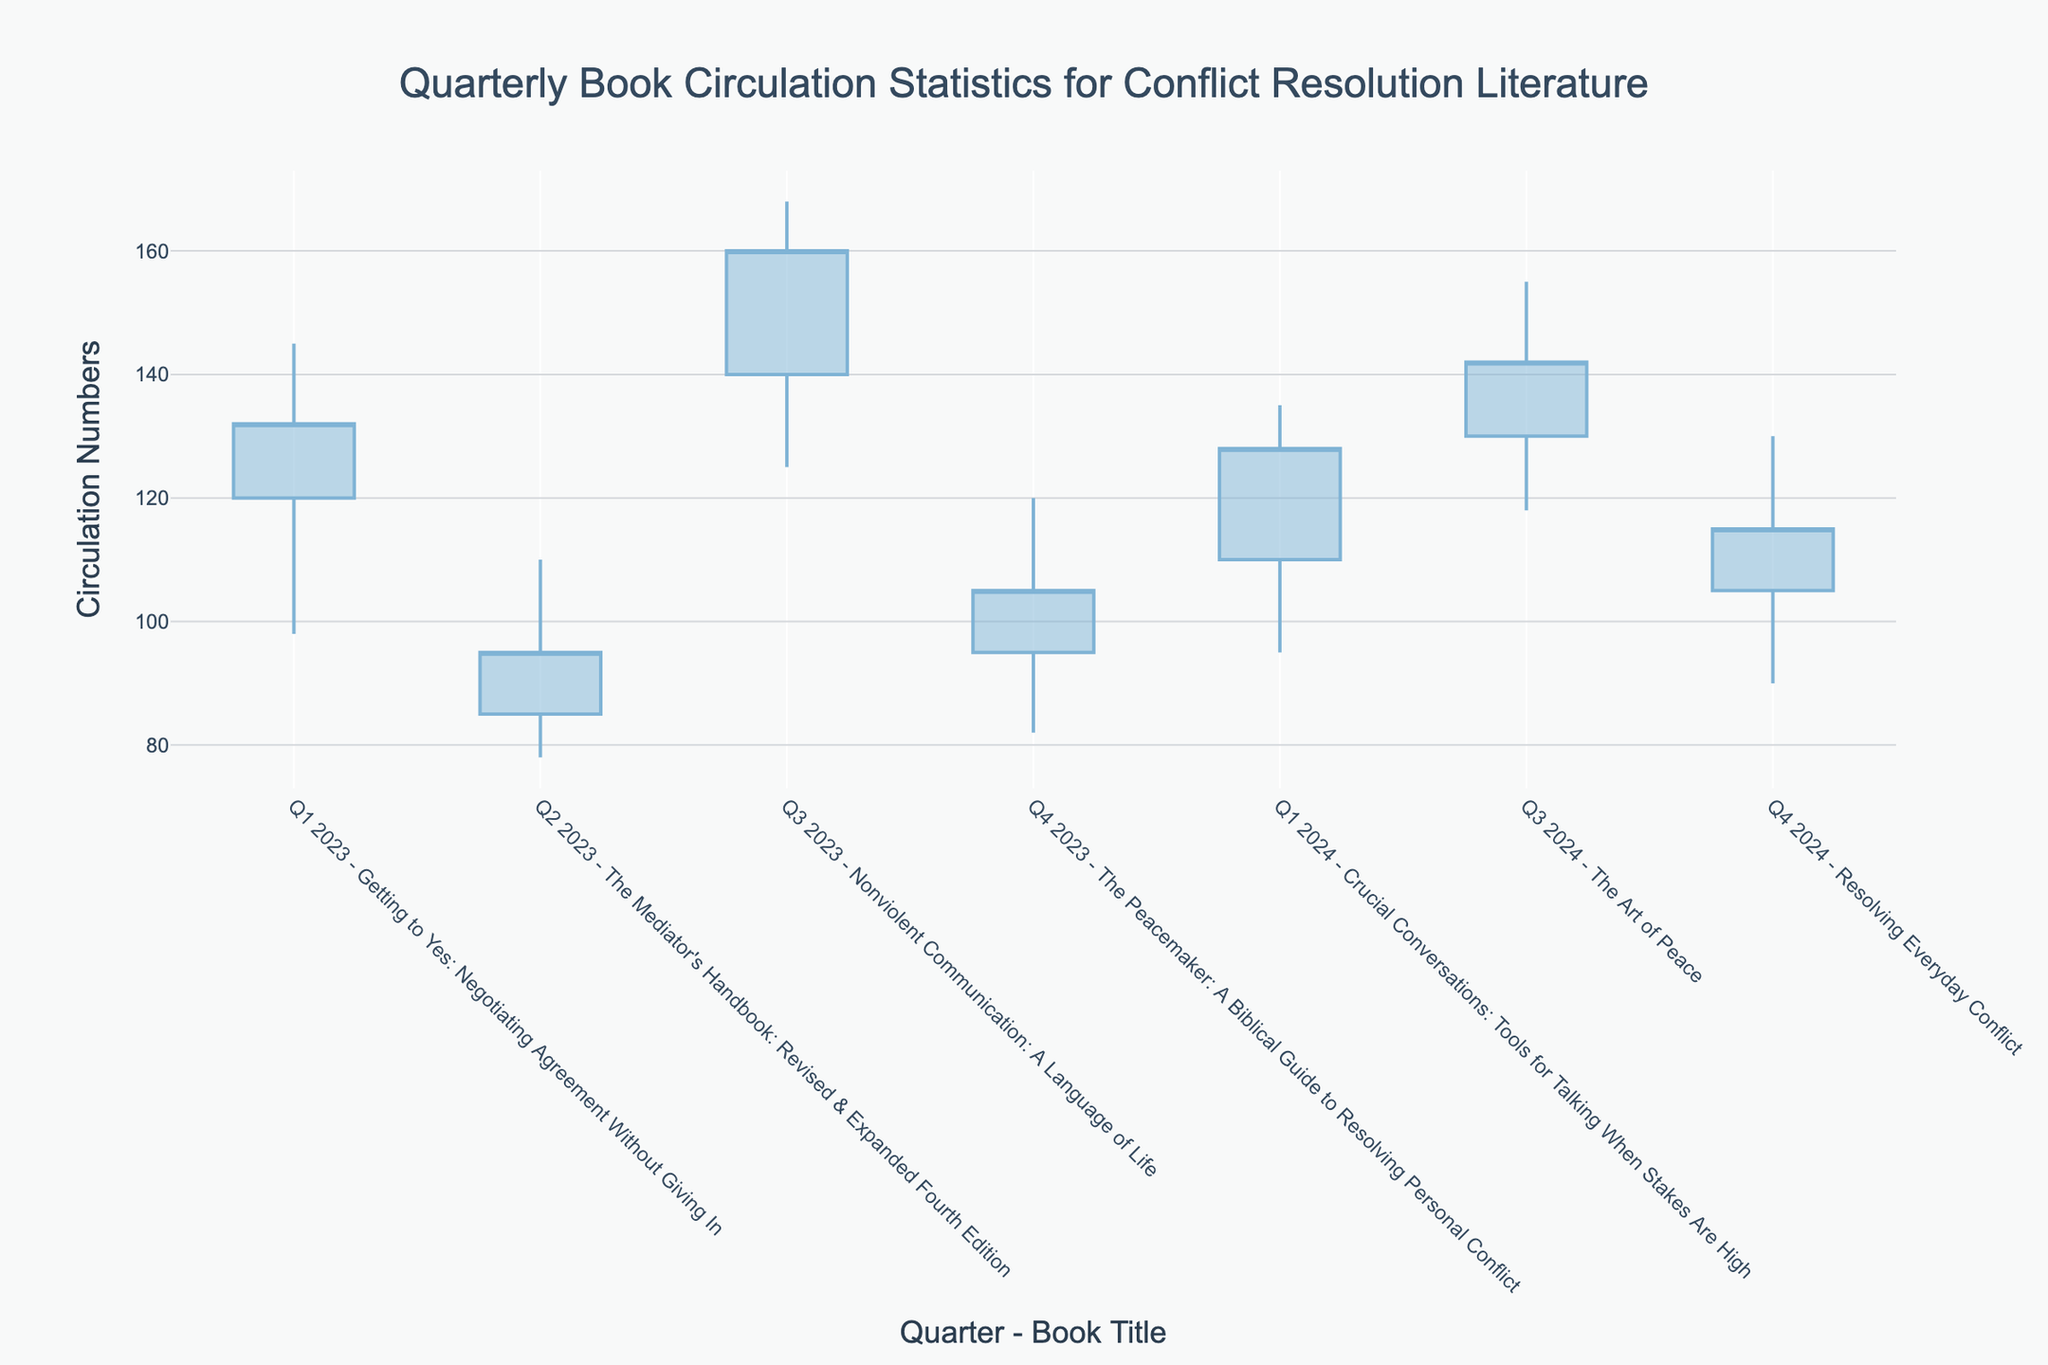What's the title of the chart? The chart title is displayed at the top center of the figure. It reads "Quarterly Book Circulation Statistics for Conflict Resolution Literature".
Answer: Quarterly Book Circulation Statistics for Conflict Resolution Literature How many data points are represented in the chart? Each quarter and book title combination represents one data point. Counting them, there are seven pairs of quarters and book titles.
Answer: 7 What's the highest circulation number recorded for "Nonviolent Communication: A Language of Life" in Q3 2023? The highest circulation number recorded for this book is indicated by the top of the candlestick for Q3 2023.
Answer: 168 What's the closing circulation number for "The Peacemaker: A Biblical Guide to Resolving Personal Conflict" in Q4 2023? The closing circulation number is shown at the end of the candlestick for Q4 2023.
Answer: 105 How does the lowest circulation number for "Crucial Conversations: Tools for Talking When Stakes Are High" in Q1 2024 compare to the lowest number for "The Mediator's Handbook" in Q2 2023? The lowest numbers are displayed by the bottom of the candlesticks for Q1 2024 and Q2 2023. For Q1 2024, it is 95, and for Q2 2023, it is 78, hence Q2 2023 has the lower number.
Answer: Q2 2023 is lower What is the average closing circulation number for all the books in 2023? To calculate this, sum the closing numbers for 2023 and divide by the number of data points in 2023:
(132 + 95 + 160 + 105) / 4 = 492 / 4 = 123
Answer: 123 Identify a book with a decreasing circulation trend from opening to closing in its respective quarter. A book has a decreasing trend if its closing number is lower than its opening number. From the figure, "The Mediator's Handbook" in Q2 2023 has an opening of 85 and a closing of 95, which is incorrect; therefore, the correct book must be scrutinized. On close inspection, there seems no clear decreasing opening to closing count as all closing numbers appear larger in the current data provided.
Answer: No clear decreasing trend Which quarter recorded the highest overall closing circulation numbers, and what's the quarter and title combination with that number? By examining the closing values across all quarters, the highest closing number is 160 for Q3 2023 for "Nonviolent Communication: A Language of Life".
Answer: Q3 2023, "Nonviolent Communication: A Language of Life" 